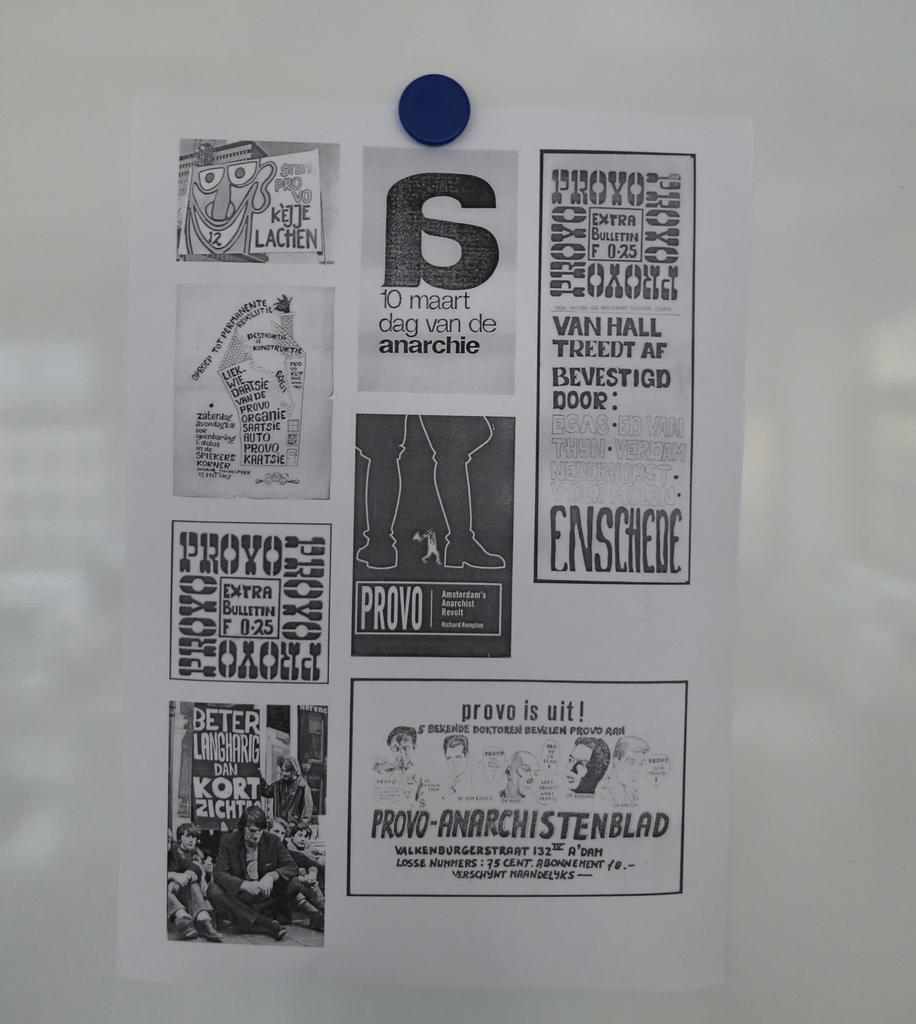What is the main subject of the image? The main subject of the image is papers pasted on a board. Can you describe the arrangement of the papers on the board? Unfortunately, the arrangement of the papers cannot be determined from the given facts. What might be the purpose of having papers pasted on a board? The purpose of having papers pasted on a board could be for displaying information, organizing notes, or creating a visual representation. Can you see the ocean waves in the image? There is no mention of the ocean or waves in the given facts, so we cannot determine if they are present in the image. 